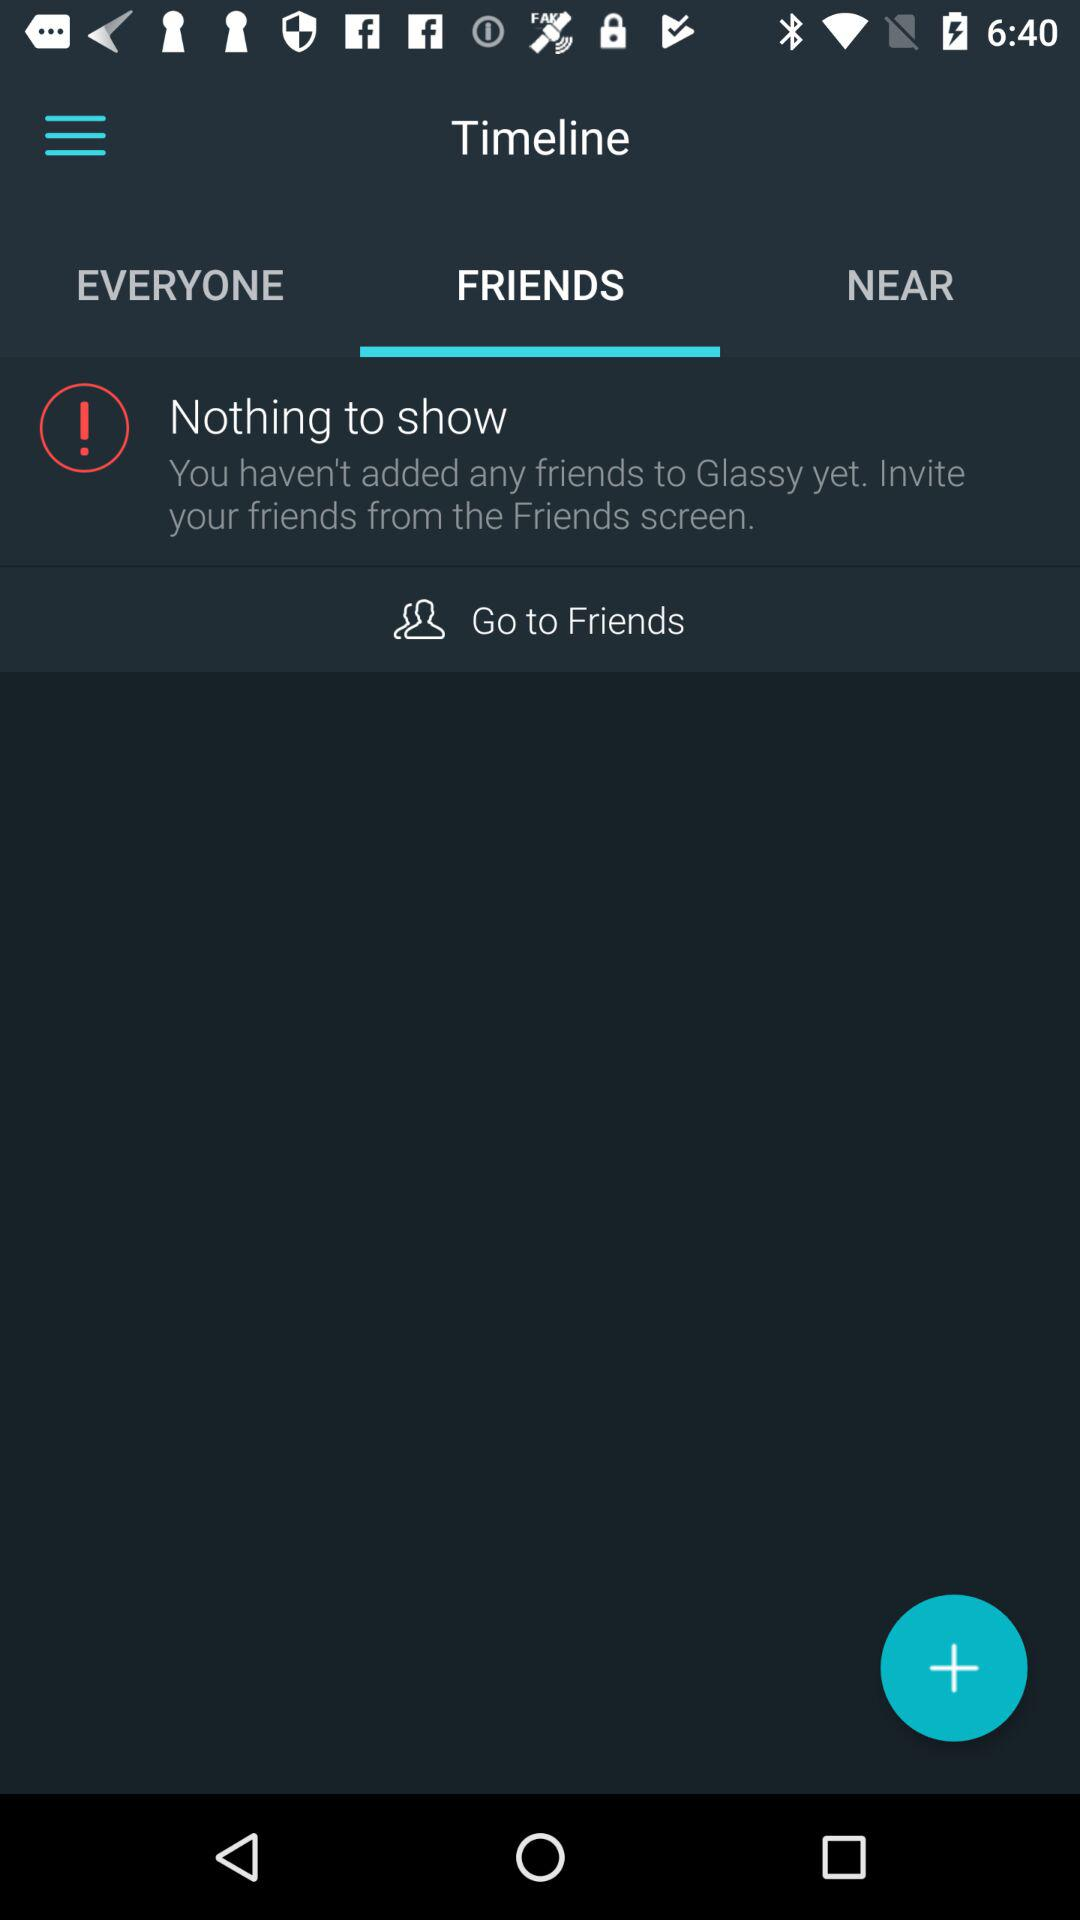How many friends can we invite?
When the provided information is insufficient, respond with <no answer>. <no answer> 